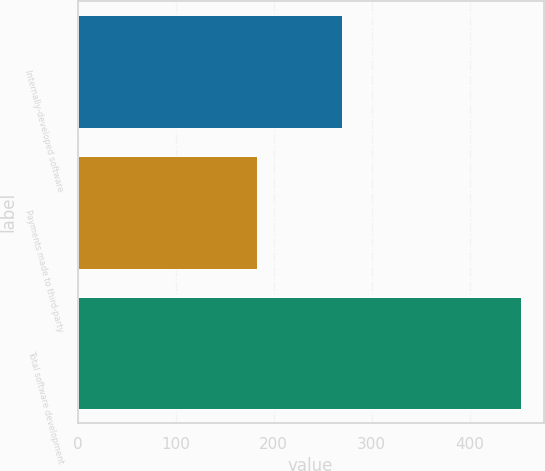Convert chart to OTSL. <chart><loc_0><loc_0><loc_500><loc_500><bar_chart><fcel>Internally-developed software<fcel>Payments made to third-party<fcel>Total software development<nl><fcel>270<fcel>183<fcel>453<nl></chart> 